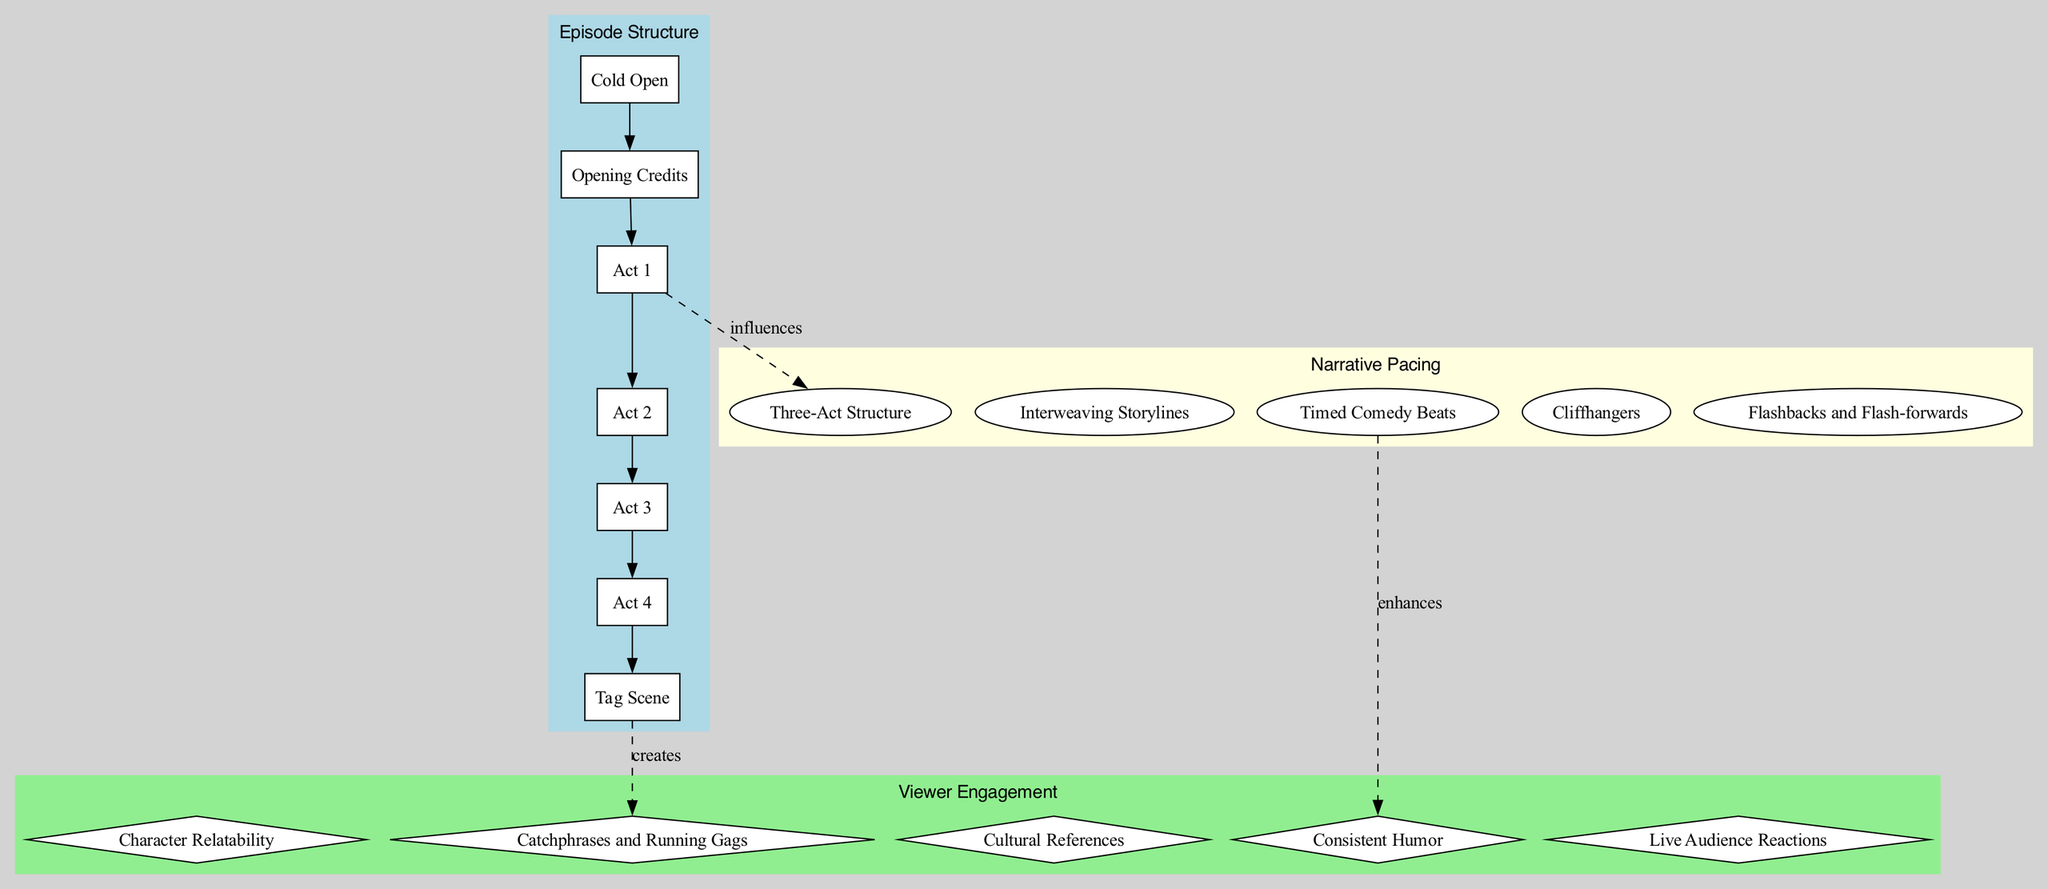What is the first element in the Episode Structure? The first element listed in the Episode Structure is "Cold Open." This can be found by looking at the elements within the "Episode Structure" cluster and identifying the first item.
Answer: Cold Open How many elements are in the Narrative Pacing category? There are five elements listed under the Narrative Pacing category. By counting the elements in that subgraph, we find that each is represented distinctly.
Answer: 5 Which element in the Viewer Engagement category relates to repeated jokes? The element concerning recurrent jokes or phrases is "Catchphrases and Running Gags." This can be identified by scanning the Viewer Engagement cluster for the description that mentions humor repetition.
Answer: Catchphrases and Running Gags What is the relationship between Act 3 and the Three-Act Structure? Act 3 represents the climax of the episode, which is part of the conflict phase in the Three-Act Structure. Understanding that Act 3 is about peak tension allows us to link it to the confrontation aspect of this broader narrative model.
Answer: Climax Which element in the Narrative Pacing influences the engagement through humor? "Timed Comedy Beats" in the Narrative Pacing section is responsible for engaging viewers with precise timing of jokes. This is inferred from how it specifically aims to maintain audience laughter through rhythm.
Answer: Timed Comedy Beats How many edges connect the Episode Structure to other categories? There are three edges connecting the Episode Structure to the Narrative Pacing and Viewer Engagement categories. By examining the connections, we can determine the interaction points with other concepts.
Answer: 3 What element introduces a comedic conclusion after the main plot? The "Tag Scene" is identified as the element that provides a humorous conclusion. This is evident as it is the last item listed in the Episode Structure, often designed to leave viewers with a laugh.
Answer: Tag Scene Which two elements are connected by a dashed line indicating an influence? The elements "Act 3" from the Episode Structure and "Three-Act Structure" in Narrative Pacing are connected by a dashed line. This line indicates how one influences the other.
Answer: Act 3 and Three-Act Structure What technique in Narrative Pacing enhances cultural connection with the audience? "Cultural References" are designed to enhance audience connection and are likely drawn from the elements listed under Viewer Engagement focusing on timely relevance.
Answer: Cultural References 